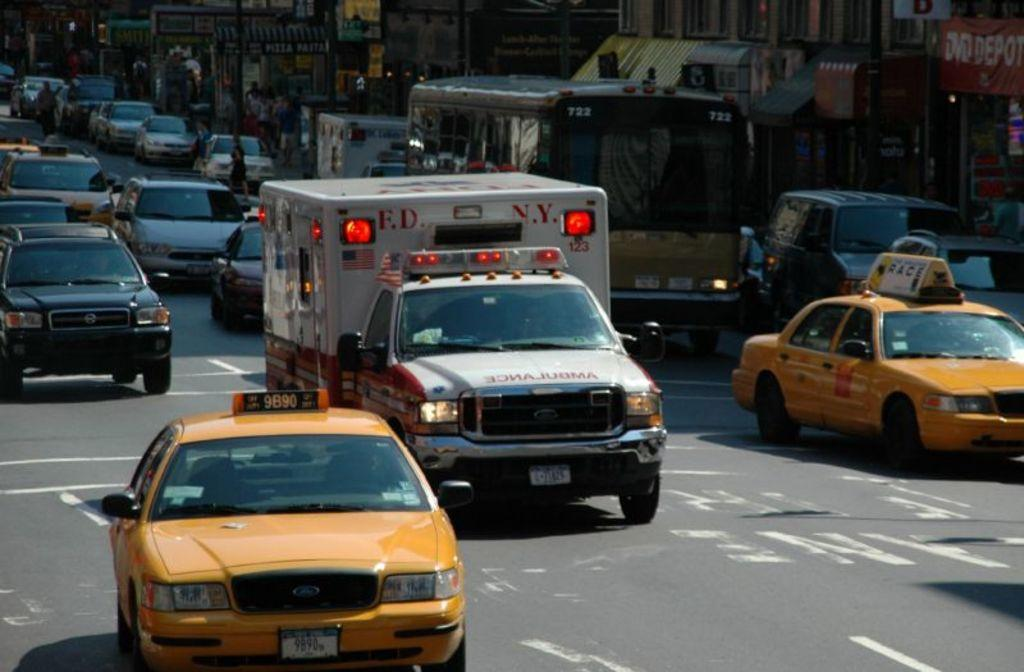<image>
Share a concise interpretation of the image provided. A ambulance with lights flashing drives down the street in traffic. 